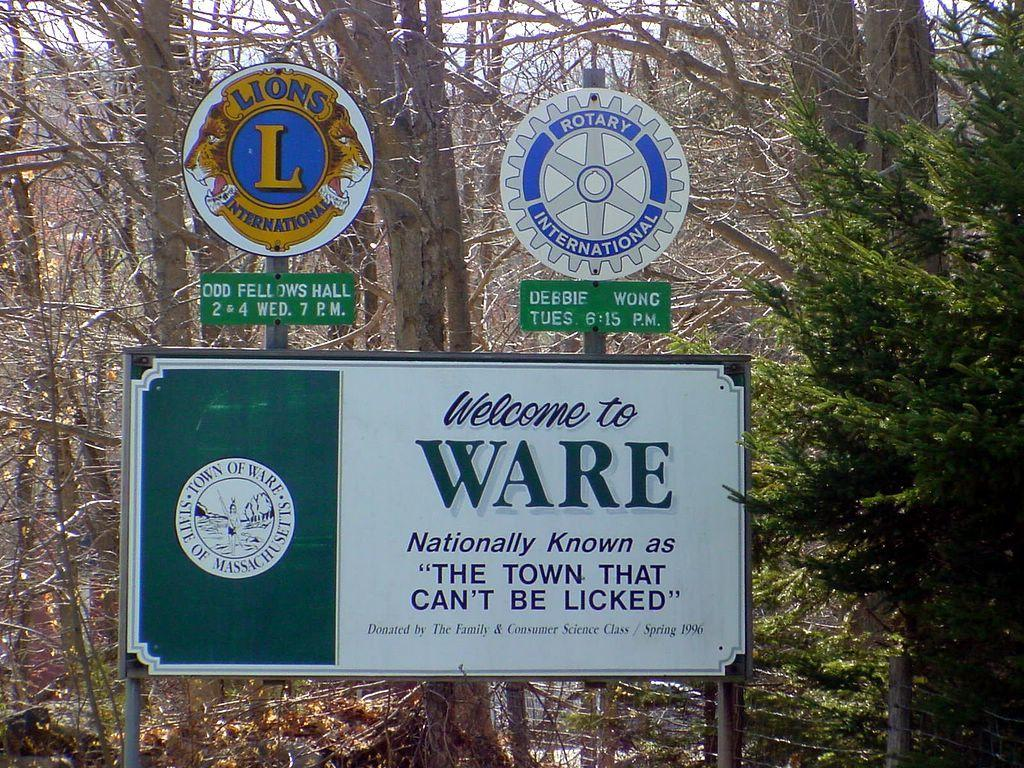<image>
Offer a succinct explanation of the picture presented. A Rotary sign on top of a Welcome to Ware sign. 